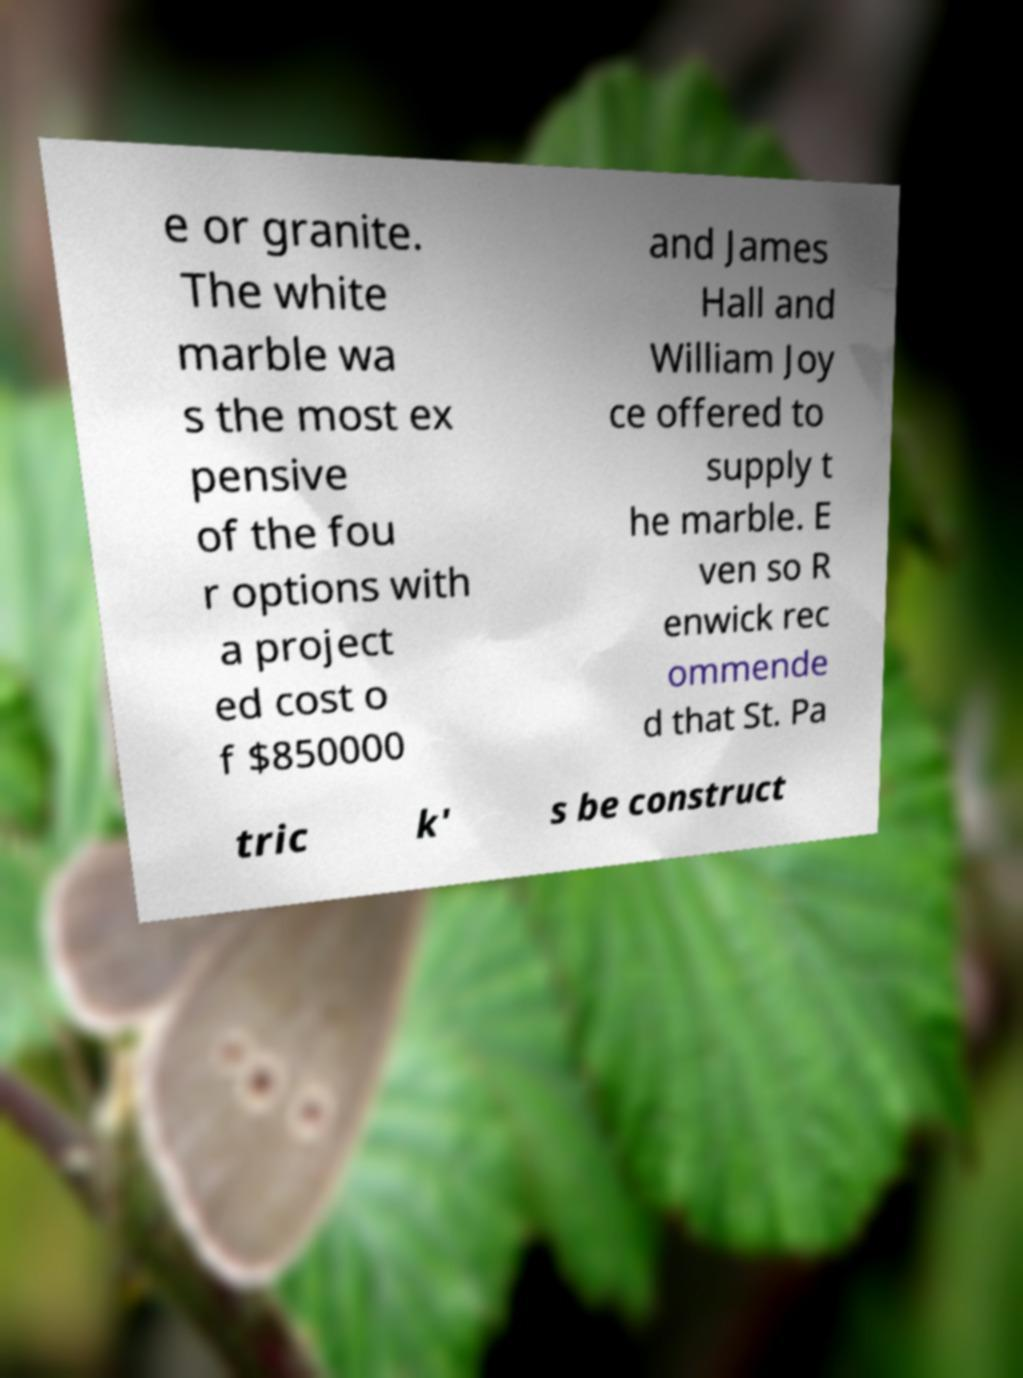For documentation purposes, I need the text within this image transcribed. Could you provide that? e or granite. The white marble wa s the most ex pensive of the fou r options with a project ed cost o f $850000 and James Hall and William Joy ce offered to supply t he marble. E ven so R enwick rec ommende d that St. Pa tric k' s be construct 